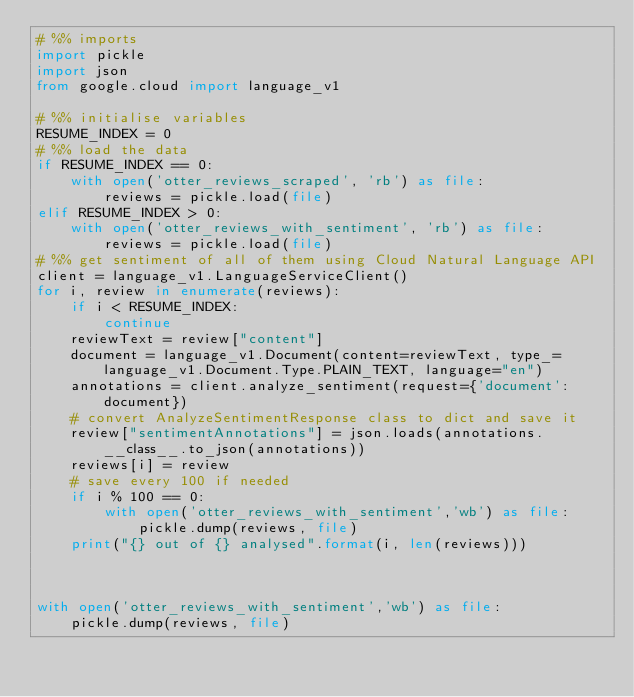<code> <loc_0><loc_0><loc_500><loc_500><_Python_># %% imports
import pickle
import json
from google.cloud import language_v1

# %% initialise variables
RESUME_INDEX = 0
# %% load the data
if RESUME_INDEX == 0:
    with open('otter_reviews_scraped', 'rb') as file:
        reviews = pickle.load(file)
elif RESUME_INDEX > 0:
    with open('otter_reviews_with_sentiment', 'rb') as file:
        reviews = pickle.load(file)
# %% get sentiment of all of them using Cloud Natural Language API
client = language_v1.LanguageServiceClient()
for i, review in enumerate(reviews):
    if i < RESUME_INDEX:
        continue
    reviewText = review["content"]
    document = language_v1.Document(content=reviewText, type_=language_v1.Document.Type.PLAIN_TEXT, language="en")
    annotations = client.analyze_sentiment(request={'document': document})
    # convert AnalyzeSentimentResponse class to dict and save it
    review["sentimentAnnotations"] = json.loads(annotations.__class__.to_json(annotations))
    reviews[i] = review
    # save every 100 if needed
    if i % 100 == 0:
        with open('otter_reviews_with_sentiment','wb') as file:
            pickle.dump(reviews, file)
    print("{} out of {} analysed".format(i, len(reviews)))



with open('otter_reviews_with_sentiment','wb') as file:
    pickle.dump(reviews, file)
</code> 